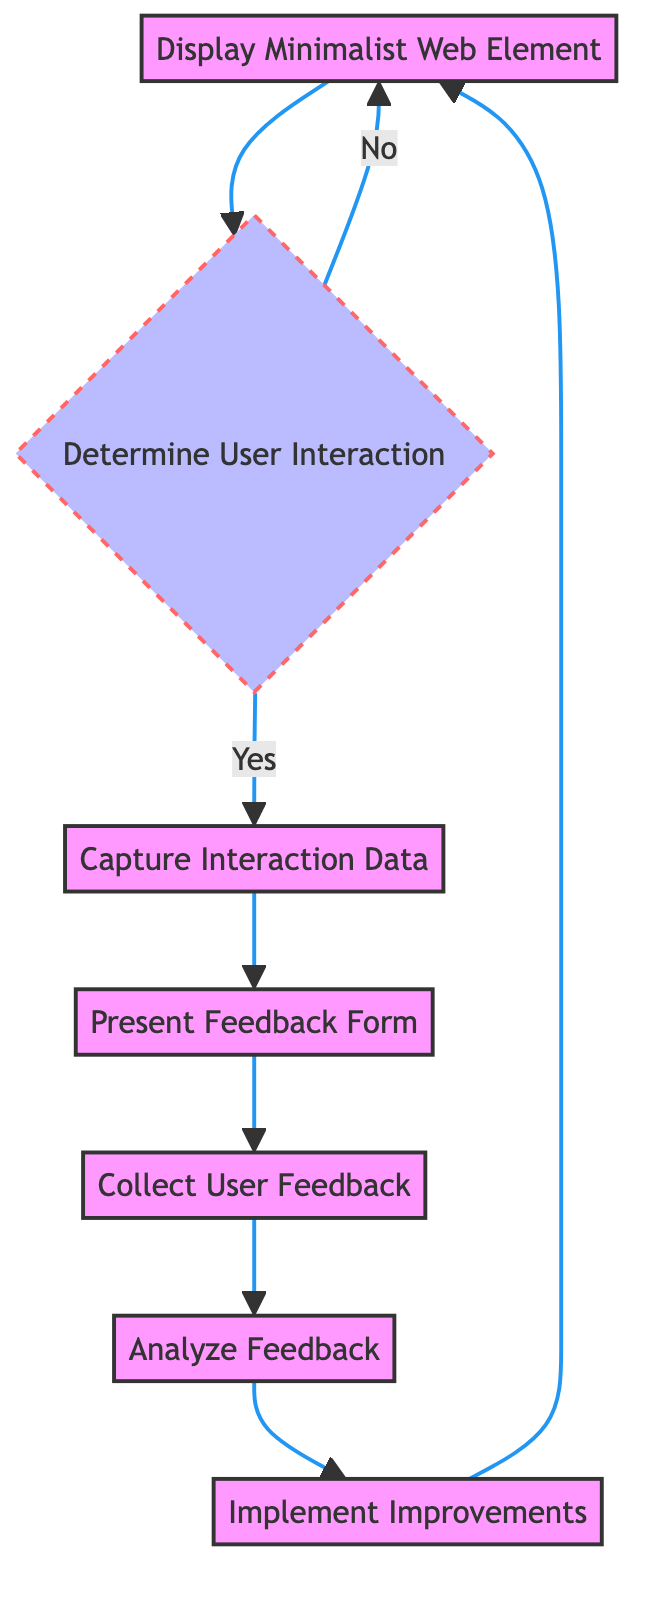What is the first step displayed in the diagram? The diagram starts with the "Display Minimalist Web Element" process, which indicates that displaying the element is the first action in the flow.
Answer: Display Minimalist Web Element How many processes are there in the diagram? By counting the distinct processes in the flowchart, we find there are six processes: "Display Minimalist Web Element", "Capture Interaction Data", "Present Feedback Form", "Collect User Feedback", "Analyze Feedback", and "Implement Improvements".
Answer: 6 What happens if the user does not interact with the minimalist web element? If the user does not interact, the flowchart indicates that it loops back to the "Display Minimalist Web Element", meaning the system will display the element again without moving to the next steps.
Answer: Loop to Display Minimalist Web Element What data is recorded when capturing user interactions? The flowchart indicates that the "Capture Interaction Data" process records data such as clicks, time spent, and navigation patterns, which provide quantitative insights into user interactions.
Answer: Clicks, time spent, navigation patterns What follows "Collect User Feedback" in the sequence? The next step in the flowchart after "Collect User Feedback" is "Analyze Feedback", which suggests that feedback gathering is directly followed by its analysis for insights.
Answer: Analyze Feedback What decision is made after displaying the minimalist web element? The decision made is to determine whether the user interacts with the displayed element, which leads to either capturing interaction data or returning to the display step.
Answer: Determine User Interaction How many total nodes are present in the diagram? Counting all unique elements in the flowchart, including processes and decisions, we find a total of seven nodes: six processes and one decision node.
Answer: 7 What process leads to the implementation of improvements? The "Implement Improvements" process follows the "Analyze Feedback" process, meaning that insights gained from feedback analysis lead to making enhancements.
Answer: Analyze Feedback What is collected in the "Collect User Feedback" process? The process focuses on gathering qualitative feedback from users regarding their experience and satisfaction, which is crucial for understanding user engagement.
Answer: Qualitative feedback 